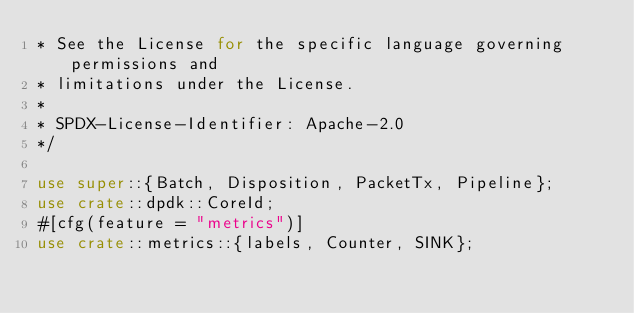<code> <loc_0><loc_0><loc_500><loc_500><_Rust_>* See the License for the specific language governing permissions and
* limitations under the License.
*
* SPDX-License-Identifier: Apache-2.0
*/

use super::{Batch, Disposition, PacketTx, Pipeline};
use crate::dpdk::CoreId;
#[cfg(feature = "metrics")]
use crate::metrics::{labels, Counter, SINK};</code> 